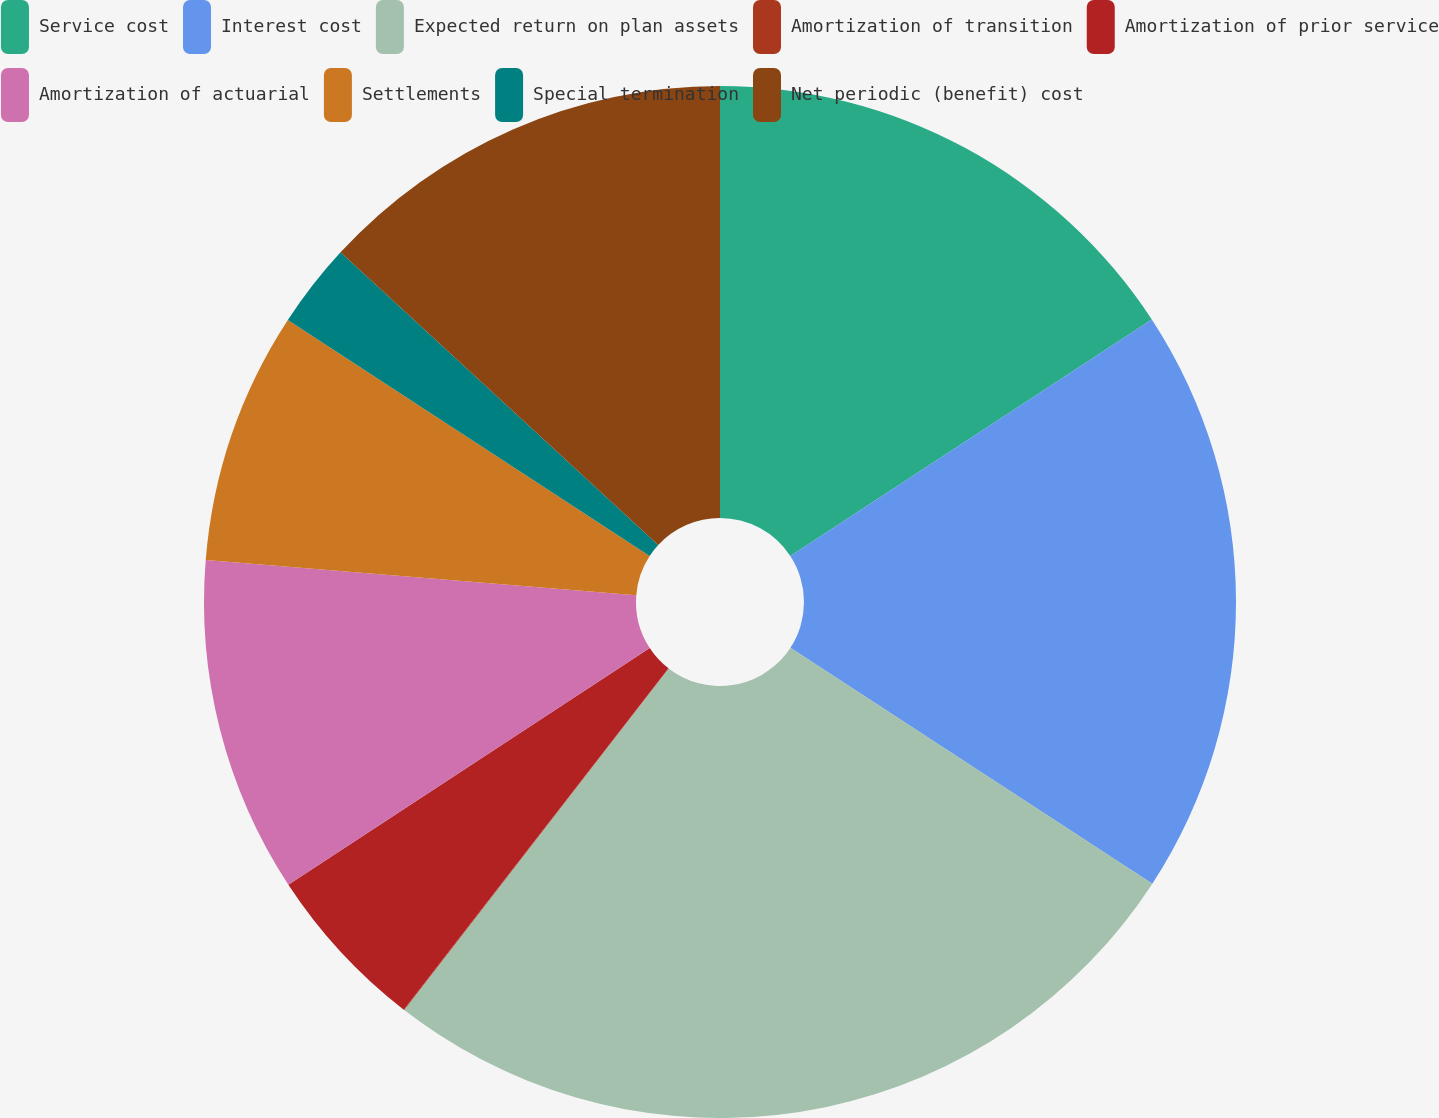Convert chart to OTSL. <chart><loc_0><loc_0><loc_500><loc_500><pie_chart><fcel>Service cost<fcel>Interest cost<fcel>Expected return on plan assets<fcel>Amortization of transition<fcel>Amortization of prior service<fcel>Amortization of actuarial<fcel>Settlements<fcel>Special termination<fcel>Net periodic (benefit) cost<nl><fcel>15.78%<fcel>18.41%<fcel>26.29%<fcel>0.02%<fcel>5.27%<fcel>10.53%<fcel>7.9%<fcel>2.65%<fcel>13.15%<nl></chart> 